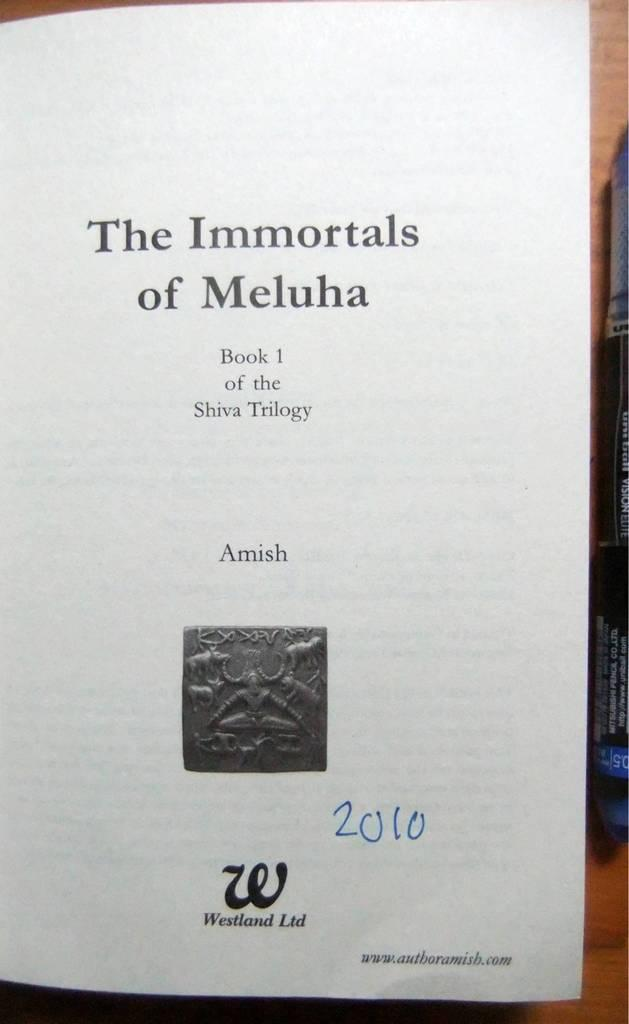<image>
Offer a succinct explanation of the picture presented. The first page of Book 1 in the Shiva Trilogy by Amish. 